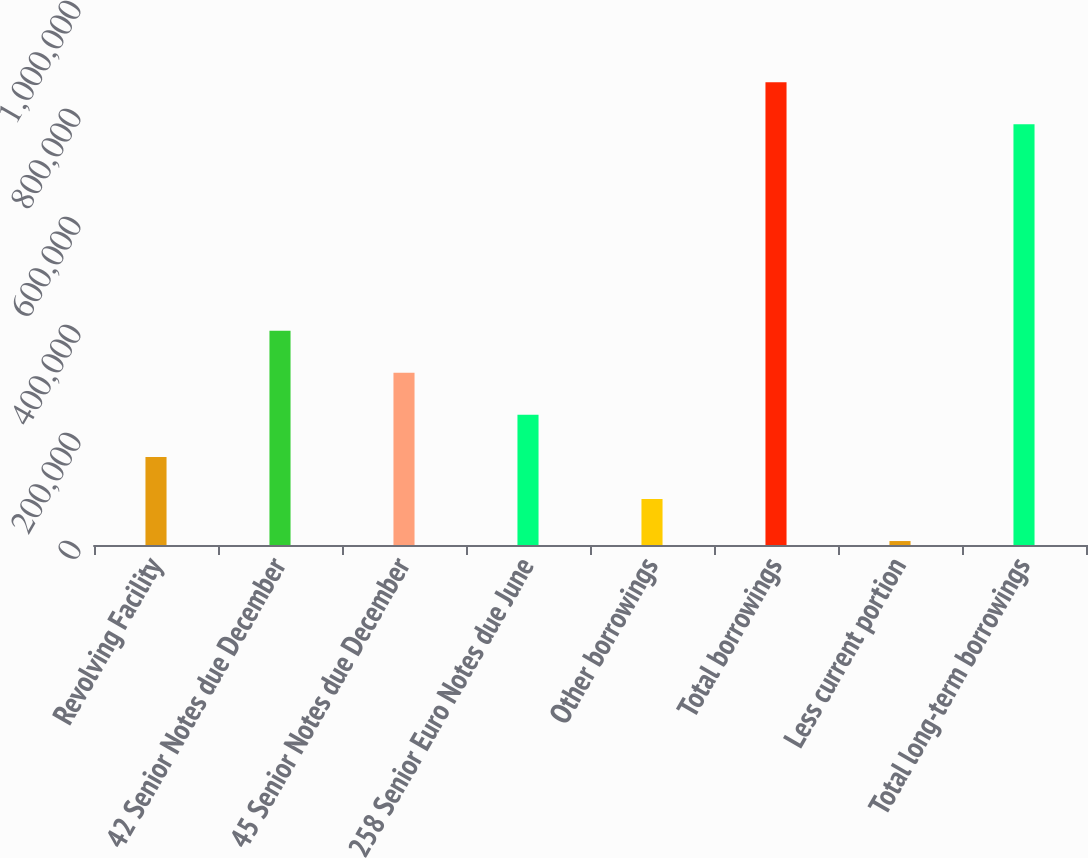Convert chart to OTSL. <chart><loc_0><loc_0><loc_500><loc_500><bar_chart><fcel>Revolving Facility<fcel>42 Senior Notes due December<fcel>45 Senior Notes due December<fcel>258 Senior Euro Notes due June<fcel>Other borrowings<fcel>Total borrowings<fcel>Less current portion<fcel>Total long-term borrowings<nl><fcel>163183<fcel>396956<fcel>319031<fcel>241107<fcel>85259.1<fcel>857165<fcel>7335<fcel>779241<nl></chart> 